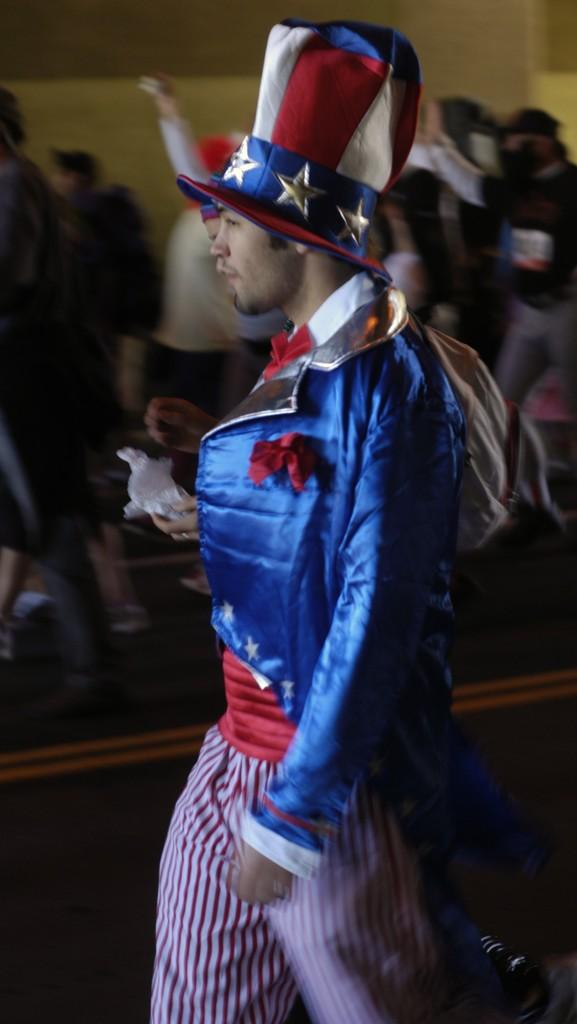What is happening in the image? There are people on the road in the image. Can you describe any specific person in the image? There is a man wearing a cap among the people. How would you describe the background of the image? The background of the image is blurry. What can be seen in the distance in the image? There is a wall visible in the background of the image. What type of juice is being served at the volleyball game in the image? There is no juice or volleyball game present in the image; it features people on the road with a man wearing a cap, and a blurry background with a visible wall. 